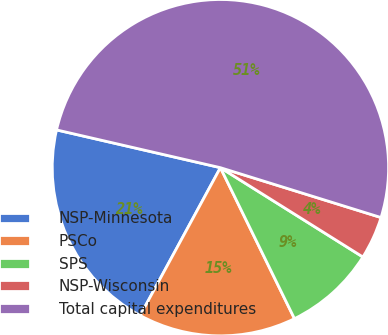Convert chart to OTSL. <chart><loc_0><loc_0><loc_500><loc_500><pie_chart><fcel>NSP-Minnesota<fcel>PSCo<fcel>SPS<fcel>NSP-Wisconsin<fcel>Total capital expenditures<nl><fcel>20.69%<fcel>15.17%<fcel>8.83%<fcel>4.12%<fcel>51.18%<nl></chart> 